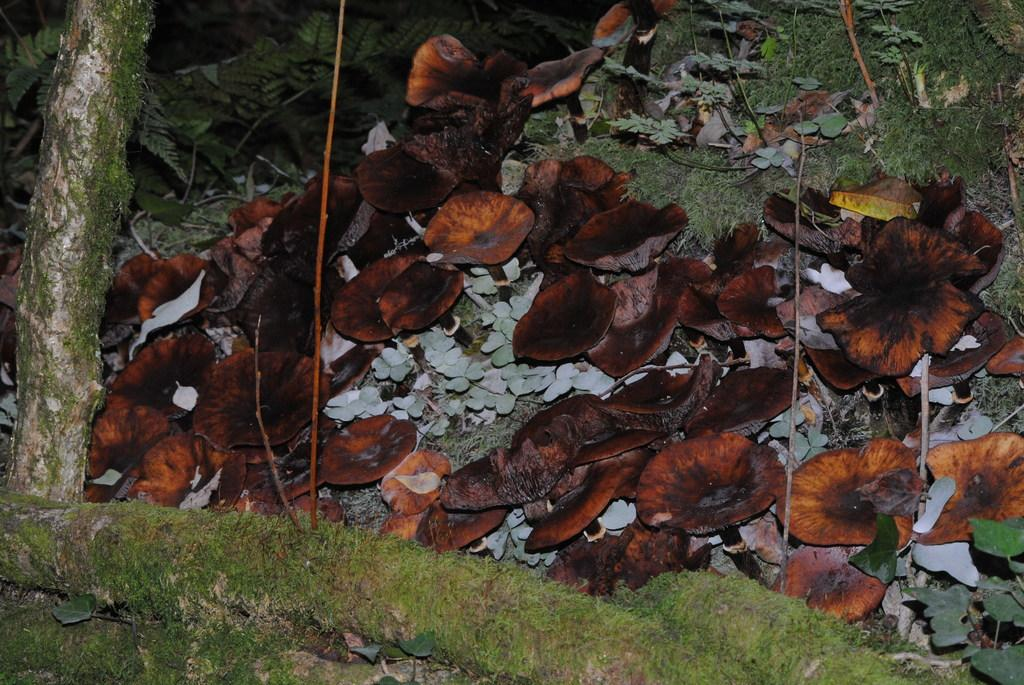What color are the leaves in the image? The leaves in the image are brown. What type of vegetation is present in the image? There is green grass in the image. What part of the tree is visible in the image? Tree trunks are visible in the image. Can you see the ocean in the image? No, there is no ocean present in the image. What type of fabric is draped over the tree in the image? There is no fabric, such as linen, present in the image. 